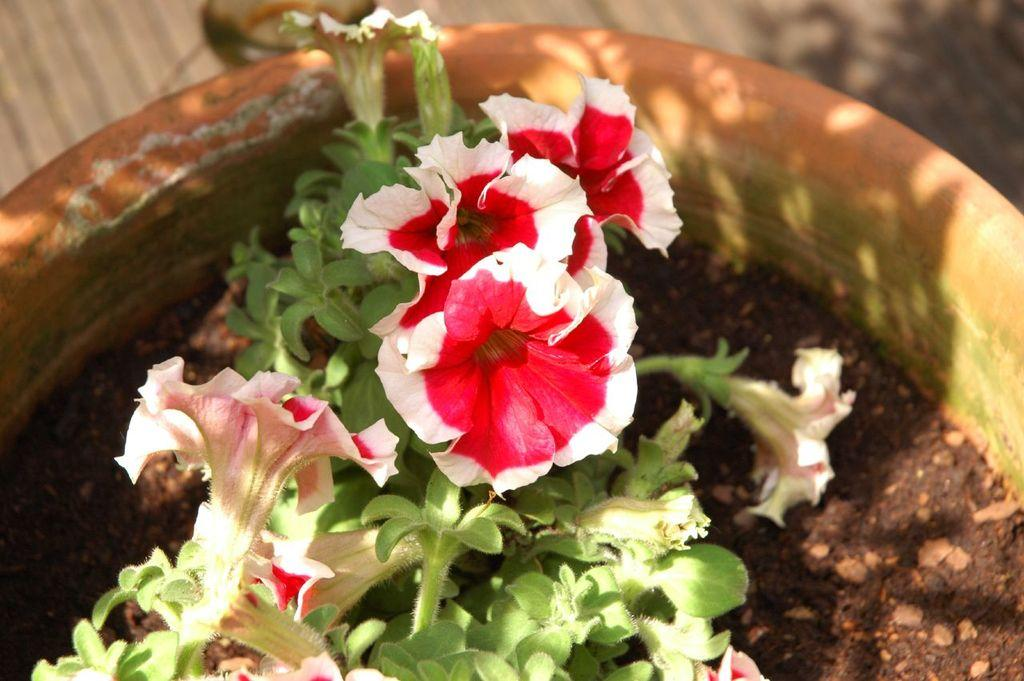What type of plant can be seen in the image? There is a flower in the image. Are there any other plants visible in the image? Yes, there is a house plant in the image. Can you tell me how many coastlines are visible in the image? There are no coastlines visible in the image; it features a flower and a house plant. What type of animal can be seen interacting with the house plant in the image? There are no animals present in the image; it only features a flower and a house plant. 